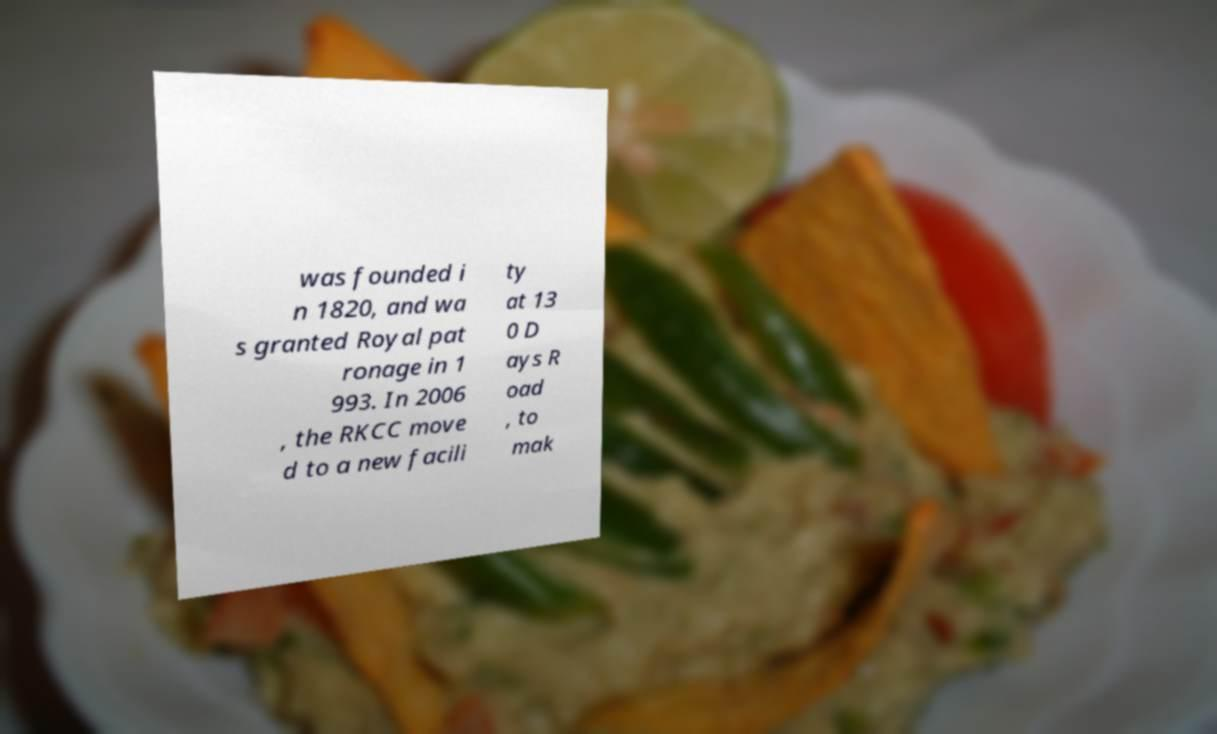Could you extract and type out the text from this image? was founded i n 1820, and wa s granted Royal pat ronage in 1 993. In 2006 , the RKCC move d to a new facili ty at 13 0 D ays R oad , to mak 